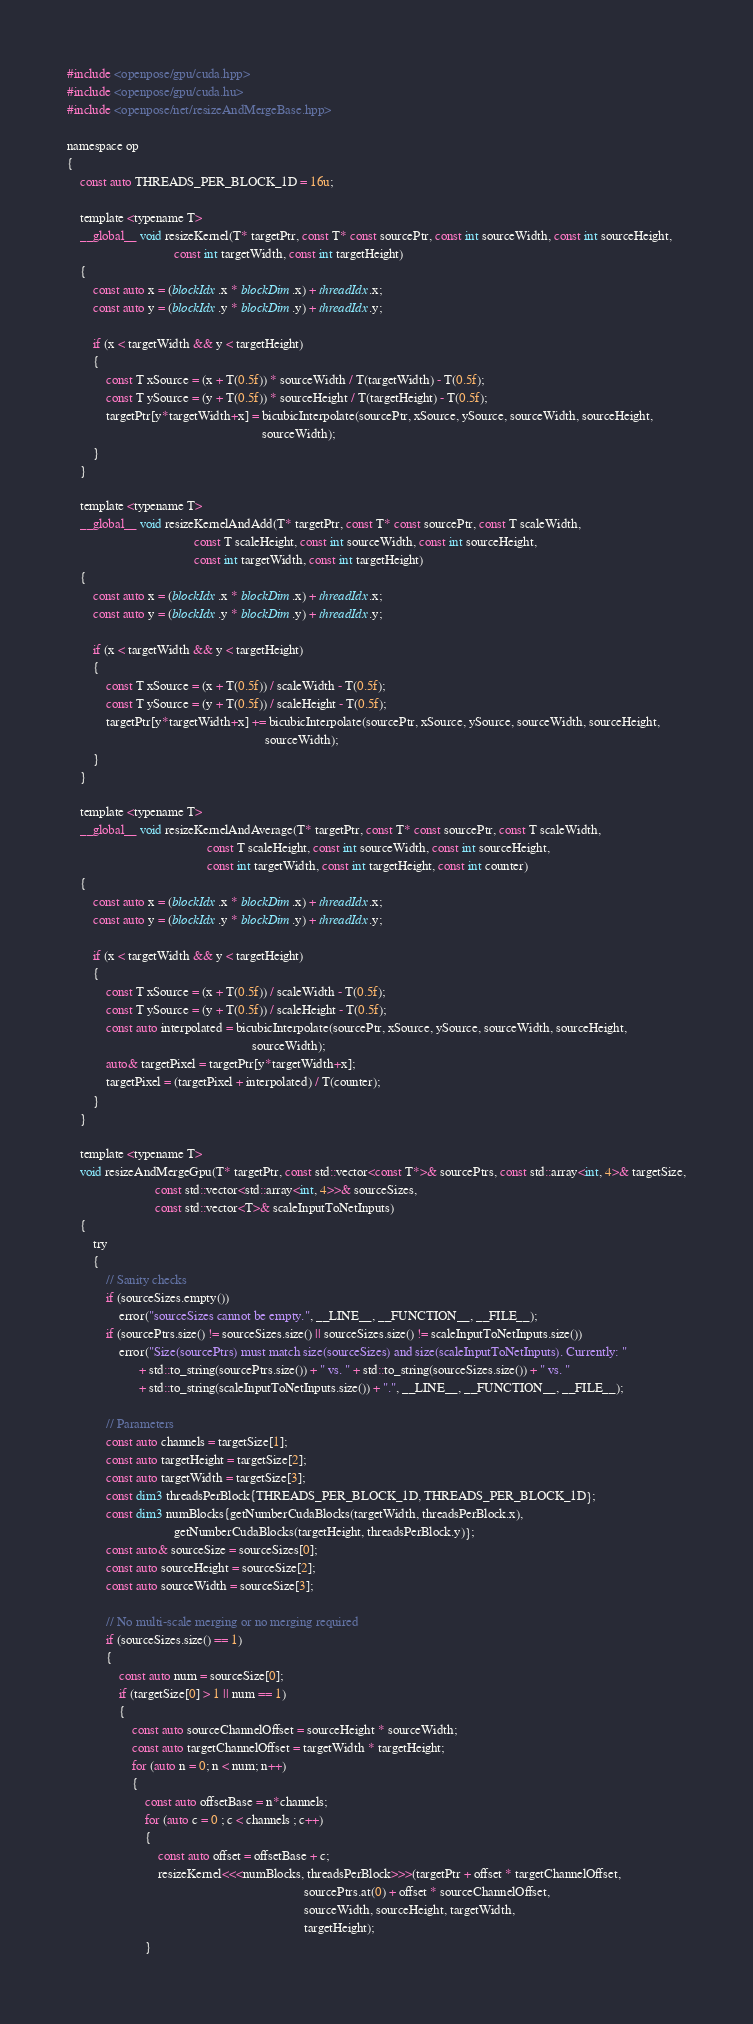Convert code to text. <code><loc_0><loc_0><loc_500><loc_500><_Cuda_>#include <openpose/gpu/cuda.hpp>
#include <openpose/gpu/cuda.hu>
#include <openpose/net/resizeAndMergeBase.hpp>

namespace op
{
    const auto THREADS_PER_BLOCK_1D = 16u;

    template <typename T>
    __global__ void resizeKernel(T* targetPtr, const T* const sourcePtr, const int sourceWidth, const int sourceHeight,
                                 const int targetWidth, const int targetHeight)
    {
        const auto x = (blockIdx.x * blockDim.x) + threadIdx.x;
        const auto y = (blockIdx.y * blockDim.y) + threadIdx.y;

        if (x < targetWidth && y < targetHeight)
        {
            const T xSource = (x + T(0.5f)) * sourceWidth / T(targetWidth) - T(0.5f);
            const T ySource = (y + T(0.5f)) * sourceHeight / T(targetHeight) - T(0.5f);
            targetPtr[y*targetWidth+x] = bicubicInterpolate(sourcePtr, xSource, ySource, sourceWidth, sourceHeight,
                                                            sourceWidth);
        }
    }

    template <typename T>
    __global__ void resizeKernelAndAdd(T* targetPtr, const T* const sourcePtr, const T scaleWidth,
                                       const T scaleHeight, const int sourceWidth, const int sourceHeight,
                                       const int targetWidth, const int targetHeight)
    {
        const auto x = (blockIdx.x * blockDim.x) + threadIdx.x;
        const auto y = (blockIdx.y * blockDim.y) + threadIdx.y;

        if (x < targetWidth && y < targetHeight)
        {
            const T xSource = (x + T(0.5f)) / scaleWidth - T(0.5f);
            const T ySource = (y + T(0.5f)) / scaleHeight - T(0.5f);
            targetPtr[y*targetWidth+x] += bicubicInterpolate(sourcePtr, xSource, ySource, sourceWidth, sourceHeight,
                                                             sourceWidth);
        }
    }

    template <typename T>
    __global__ void resizeKernelAndAverage(T* targetPtr, const T* const sourcePtr, const T scaleWidth,
                                           const T scaleHeight, const int sourceWidth, const int sourceHeight,
                                           const int targetWidth, const int targetHeight, const int counter)
    {
        const auto x = (blockIdx.x * blockDim.x) + threadIdx.x;
        const auto y = (blockIdx.y * blockDim.y) + threadIdx.y;

        if (x < targetWidth && y < targetHeight)
        {
            const T xSource = (x + T(0.5f)) / scaleWidth - T(0.5f);
            const T ySource = (y + T(0.5f)) / scaleHeight - T(0.5f);
            const auto interpolated = bicubicInterpolate(sourcePtr, xSource, ySource, sourceWidth, sourceHeight,
                                                         sourceWidth);
            auto& targetPixel = targetPtr[y*targetWidth+x];
            targetPixel = (targetPixel + interpolated) / T(counter);
        }
    }

    template <typename T>
    void resizeAndMergeGpu(T* targetPtr, const std::vector<const T*>& sourcePtrs, const std::array<int, 4>& targetSize,
                           const std::vector<std::array<int, 4>>& sourceSizes,
                           const std::vector<T>& scaleInputToNetInputs)
    {
        try
        {
            // Sanity checks
            if (sourceSizes.empty())
                error("sourceSizes cannot be empty.", __LINE__, __FUNCTION__, __FILE__);
            if (sourcePtrs.size() != sourceSizes.size() || sourceSizes.size() != scaleInputToNetInputs.size())
                error("Size(sourcePtrs) must match size(sourceSizes) and size(scaleInputToNetInputs). Currently: "
                      + std::to_string(sourcePtrs.size()) + " vs. " + std::to_string(sourceSizes.size()) + " vs. "
                      + std::to_string(scaleInputToNetInputs.size()) + ".", __LINE__, __FUNCTION__, __FILE__);

            // Parameters
            const auto channels = targetSize[1];
            const auto targetHeight = targetSize[2];
            const auto targetWidth = targetSize[3];
            const dim3 threadsPerBlock{THREADS_PER_BLOCK_1D, THREADS_PER_BLOCK_1D};
            const dim3 numBlocks{getNumberCudaBlocks(targetWidth, threadsPerBlock.x),
                                 getNumberCudaBlocks(targetHeight, threadsPerBlock.y)};
            const auto& sourceSize = sourceSizes[0];
            const auto sourceHeight = sourceSize[2];
            const auto sourceWidth = sourceSize[3];

            // No multi-scale merging or no merging required
            if (sourceSizes.size() == 1)
            {
                const auto num = sourceSize[0];
                if (targetSize[0] > 1 || num == 1)
                {
                    const auto sourceChannelOffset = sourceHeight * sourceWidth;
                    const auto targetChannelOffset = targetWidth * targetHeight;
                    for (auto n = 0; n < num; n++)
                    {
                        const auto offsetBase = n*channels;
                        for (auto c = 0 ; c < channels ; c++)
                        {
                            const auto offset = offsetBase + c;
                            resizeKernel<<<numBlocks, threadsPerBlock>>>(targetPtr + offset * targetChannelOffset,
                                                                         sourcePtrs.at(0) + offset * sourceChannelOffset,
                                                                         sourceWidth, sourceHeight, targetWidth,
                                                                         targetHeight);
                        }</code> 